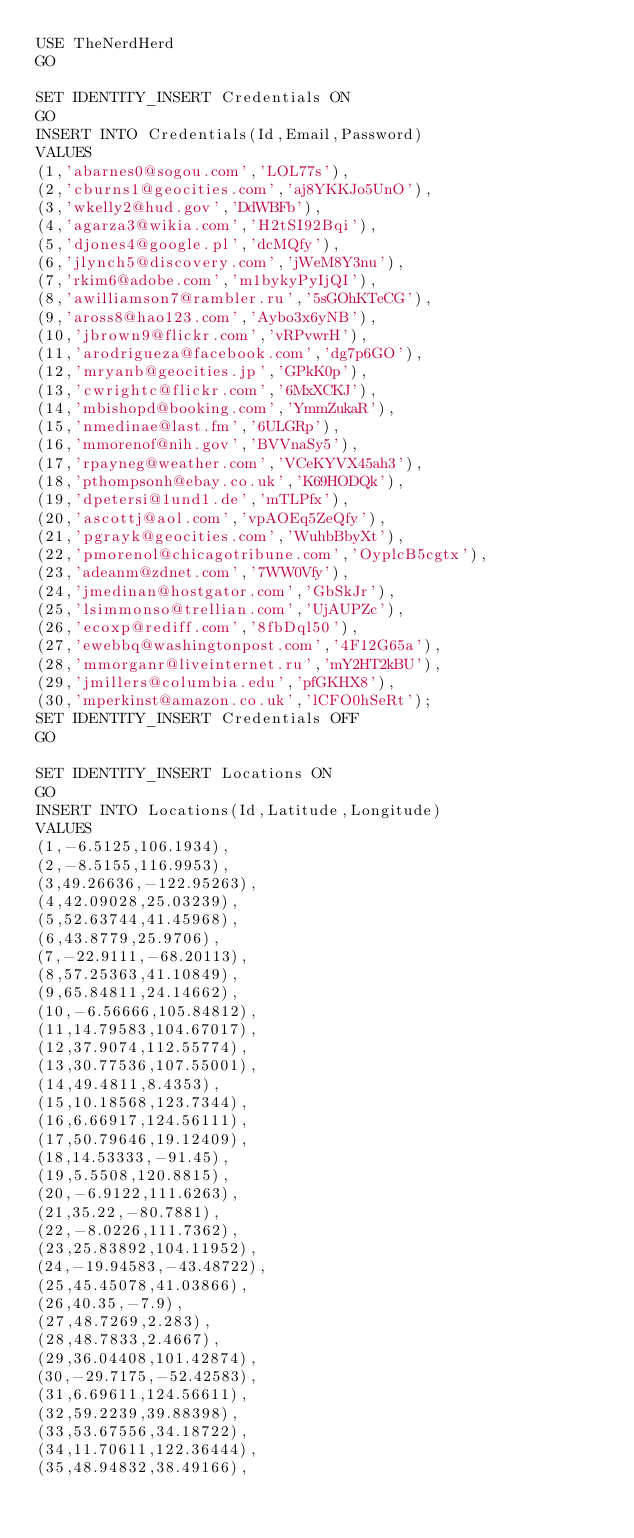Convert code to text. <code><loc_0><loc_0><loc_500><loc_500><_SQL_>USE TheNerdHerd
GO

SET IDENTITY_INSERT Credentials ON
GO
INSERT INTO Credentials(Id,Email,Password)
VALUES
(1,'abarnes0@sogou.com','LOL77s'),
(2,'cburns1@geocities.com','aj8YKKJo5UnO'),
(3,'wkelly2@hud.gov','DdWBFb'),
(4,'agarza3@wikia.com','H2tSI92Bqi'),
(5,'djones4@google.pl','dcMQfy'),
(6,'jlynch5@discovery.com','jWeM8Y3nu'),
(7,'rkim6@adobe.com','m1bykyPyIjQI'),
(8,'awilliamson7@rambler.ru','5sGOhKTeCG'),
(9,'aross8@hao123.com','Aybo3x6yNB'),
(10,'jbrown9@flickr.com','vRPvwrH'),
(11,'arodrigueza@facebook.com','dg7p6GO'),
(12,'mryanb@geocities.jp','GPkK0p'),
(13,'cwrightc@flickr.com','6MxXCKJ'),
(14,'mbishopd@booking.com','YmmZukaR'),
(15,'nmedinae@last.fm','6ULGRp'),
(16,'mmorenof@nih.gov','BVVnaSy5'),
(17,'rpayneg@weather.com','VCeKYVX45ah3'),
(18,'pthompsonh@ebay.co.uk','K69HODQk'),
(19,'dpetersi@1und1.de','mTLPfx'),
(20,'ascottj@aol.com','vpAOEq5ZeQfy'),
(21,'pgrayk@geocities.com','WuhbBbyXt'),
(22,'pmorenol@chicagotribune.com','OyplcB5cgtx'),
(23,'adeanm@zdnet.com','7WW0Vfy'),
(24,'jmedinan@hostgator.com','GbSkJr'),
(25,'lsimmonso@trellian.com','UjAUPZc'),
(26,'ecoxp@rediff.com','8fbDql50'),
(27,'ewebbq@washingtonpost.com','4F12G65a'),
(28,'mmorganr@liveinternet.ru','mY2HT2kBU'),
(29,'jmillers@columbia.edu','pfGKHX8'),
(30,'mperkinst@amazon.co.uk','lCFO0hSeRt');
SET IDENTITY_INSERT Credentials OFF
GO

SET IDENTITY_INSERT Locations ON
GO
INSERT INTO Locations(Id,Latitude,Longitude)
VALUES
(1,-6.5125,106.1934),
(2,-8.5155,116.9953),
(3,49.26636,-122.95263),
(4,42.09028,25.03239),
(5,52.63744,41.45968),
(6,43.8779,25.9706),
(7,-22.9111,-68.20113),
(8,57.25363,41.10849),
(9,65.84811,24.14662),
(10,-6.56666,105.84812),
(11,14.79583,104.67017),
(12,37.9074,112.55774),
(13,30.77536,107.55001),
(14,49.4811,8.4353),
(15,10.18568,123.7344),
(16,6.66917,124.56111),
(17,50.79646,19.12409),
(18,14.53333,-91.45),
(19,5.5508,120.8815),
(20,-6.9122,111.6263),
(21,35.22,-80.7881),
(22,-8.0226,111.7362),
(23,25.83892,104.11952),
(24,-19.94583,-43.48722),
(25,45.45078,41.03866),
(26,40.35,-7.9),
(27,48.7269,2.283),
(28,48.7833,2.4667),
(29,36.04408,101.42874),
(30,-29.7175,-52.42583),
(31,6.69611,124.56611),
(32,59.2239,39.88398),
(33,53.67556,34.18722),
(34,11.70611,122.36444),
(35,48.94832,38.49166),</code> 